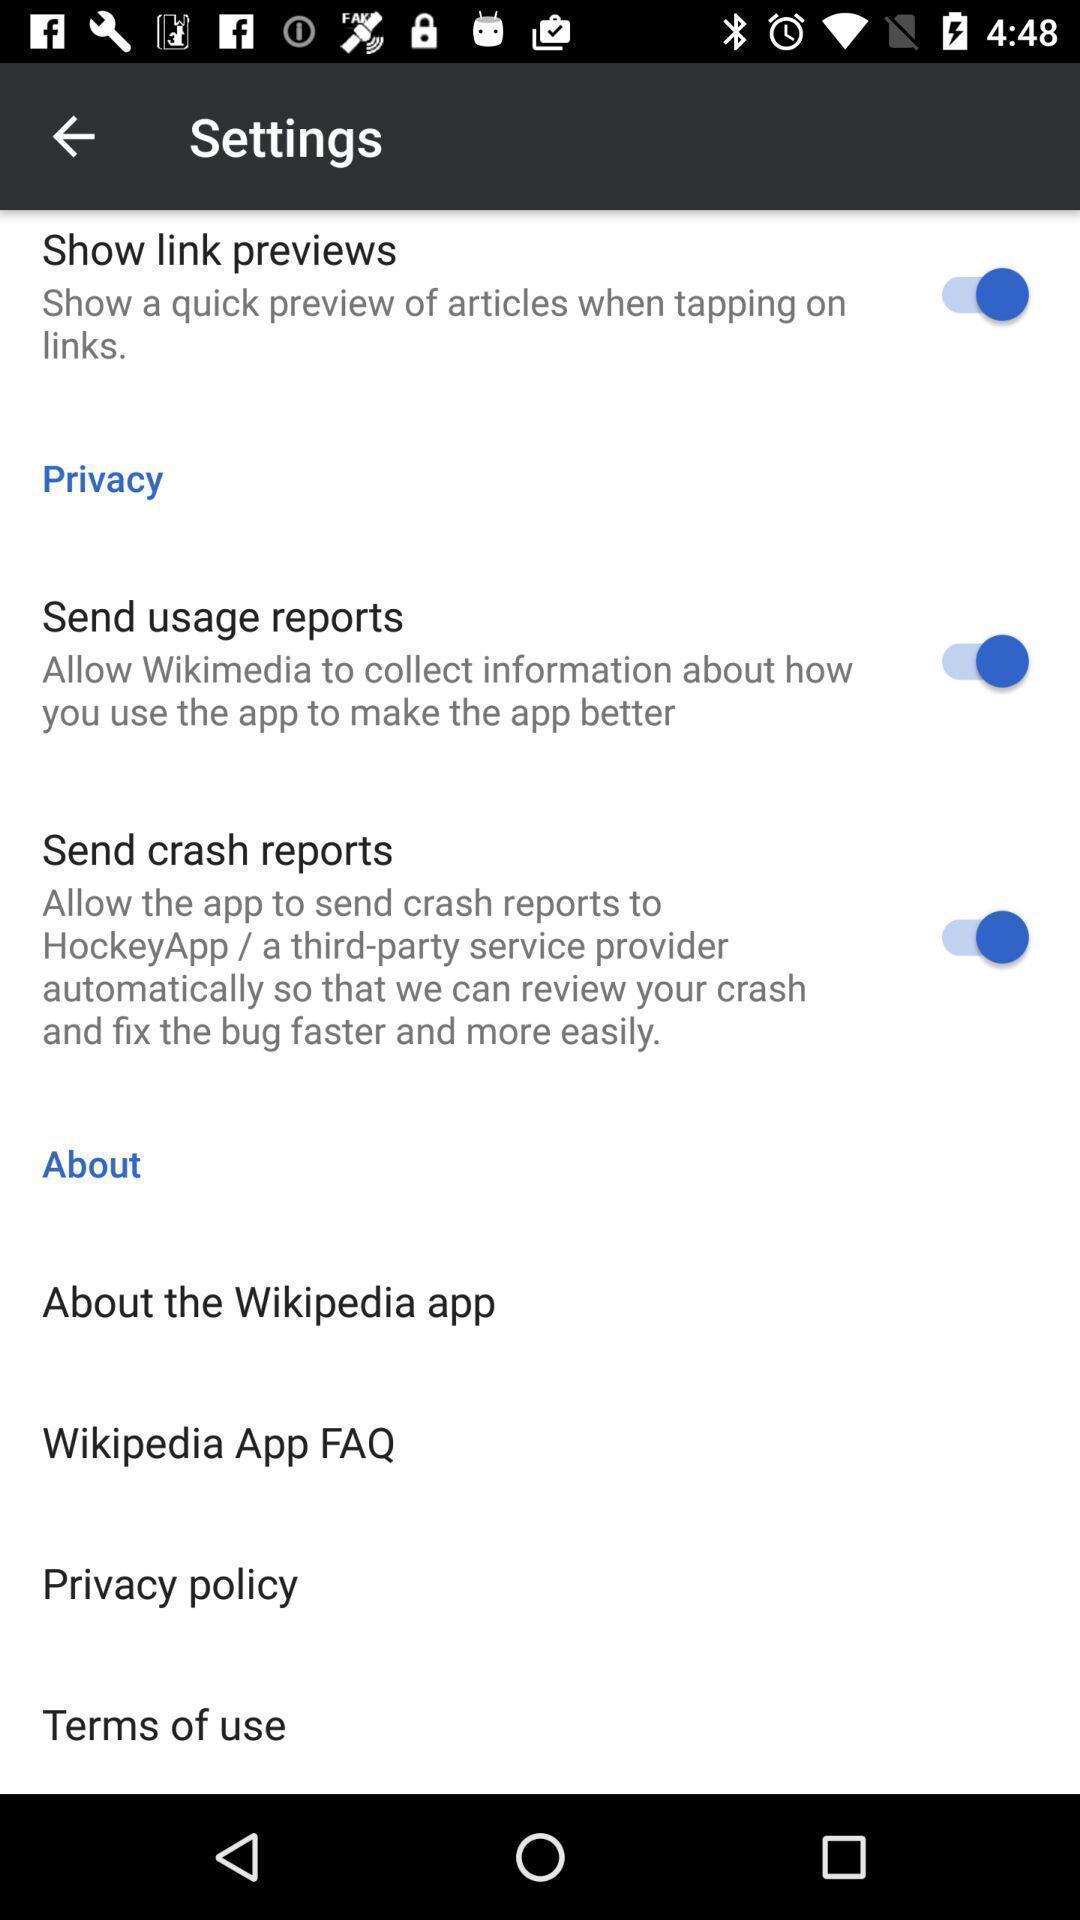Explain the elements present in this screenshot. Settings page displayed. 